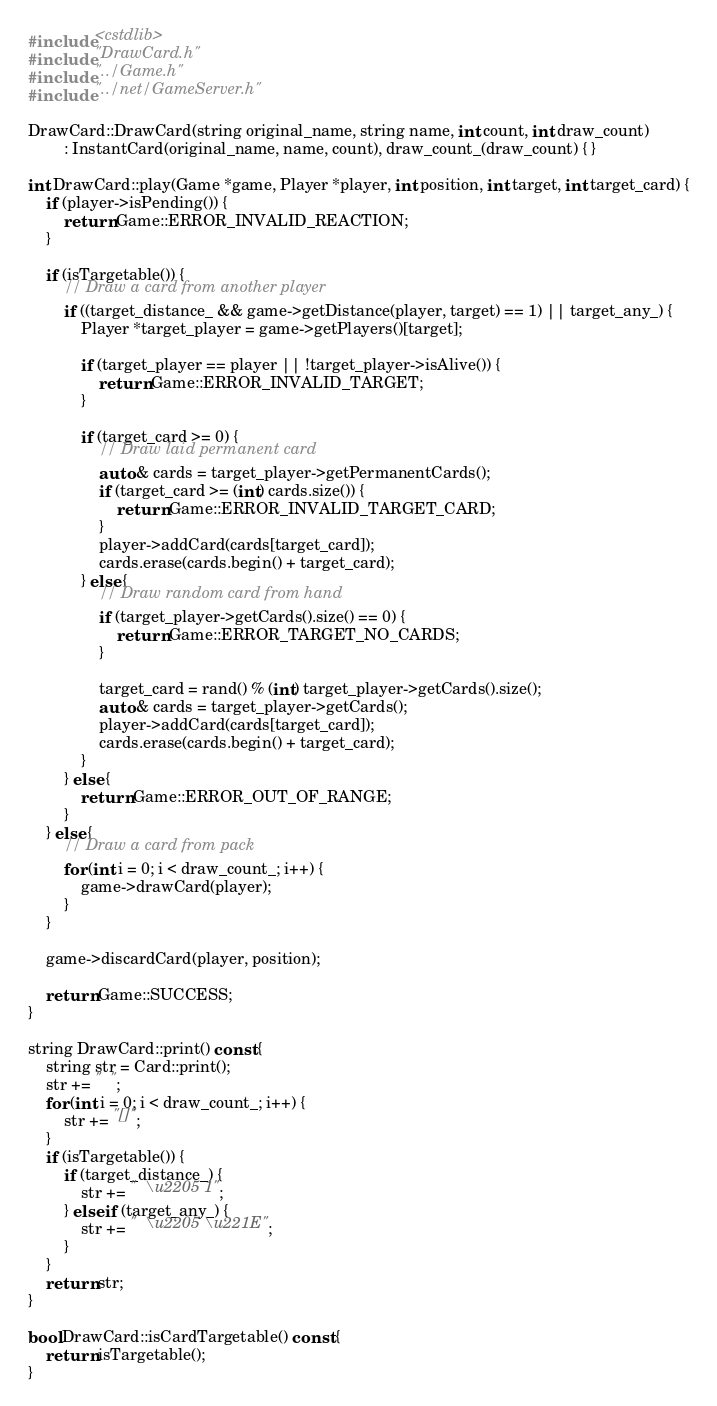Convert code to text. <code><loc_0><loc_0><loc_500><loc_500><_C++_>#include <cstdlib>
#include "DrawCard.h"
#include "../Game.h"
#include "../net/GameServer.h"

DrawCard::DrawCard(string original_name, string name, int count, int draw_count)
        : InstantCard(original_name, name, count), draw_count_(draw_count) { }

int DrawCard::play(Game *game, Player *player, int position, int target, int target_card) {
    if (player->isPending()) {
        return Game::ERROR_INVALID_REACTION;
    }

    if (isTargetable()) {
        // Draw a card from another player
        if ((target_distance_ && game->getDistance(player, target) == 1) || target_any_) {
            Player *target_player = game->getPlayers()[target];

            if (target_player == player || !target_player->isAlive()) {
                return Game::ERROR_INVALID_TARGET;
            }

            if (target_card >= 0) {
                // Draw laid permanent card
                auto & cards = target_player->getPermanentCards();
                if (target_card >= (int) cards.size()) {
                    return Game::ERROR_INVALID_TARGET_CARD;
                }
                player->addCard(cards[target_card]);
                cards.erase(cards.begin() + target_card);
            } else {
                // Draw random card from hand
                if (target_player->getCards().size() == 0) {
                    return Game::ERROR_TARGET_NO_CARDS;
                }

                target_card = rand() % (int) target_player->getCards().size();
                auto & cards = target_player->getCards();
                player->addCard(cards[target_card]);
                cards.erase(cards.begin() + target_card);
            }
        } else {
            return Game::ERROR_OUT_OF_RANGE;
        }
    } else {
        // Draw a card from pack
        for (int i = 0; i < draw_count_; i++) {
            game->drawCard(player);
        }
    }

    game->discardCard(player, position);

    return Game::SUCCESS;
}

string DrawCard::print() const {
    string str = Card::print();
    str += "  ";
    for (int i = 0; i < draw_count_; i++) {
        str += "[]";
    }
    if (isTargetable()) {
        if (target_distance_) {
            str += "  \u2205 1";
        } else if (target_any_) {
            str += "  \u2205 \u221E";
        }
    }
    return str;
}

bool DrawCard::isCardTargetable() const {
    return isTargetable();
}
</code> 